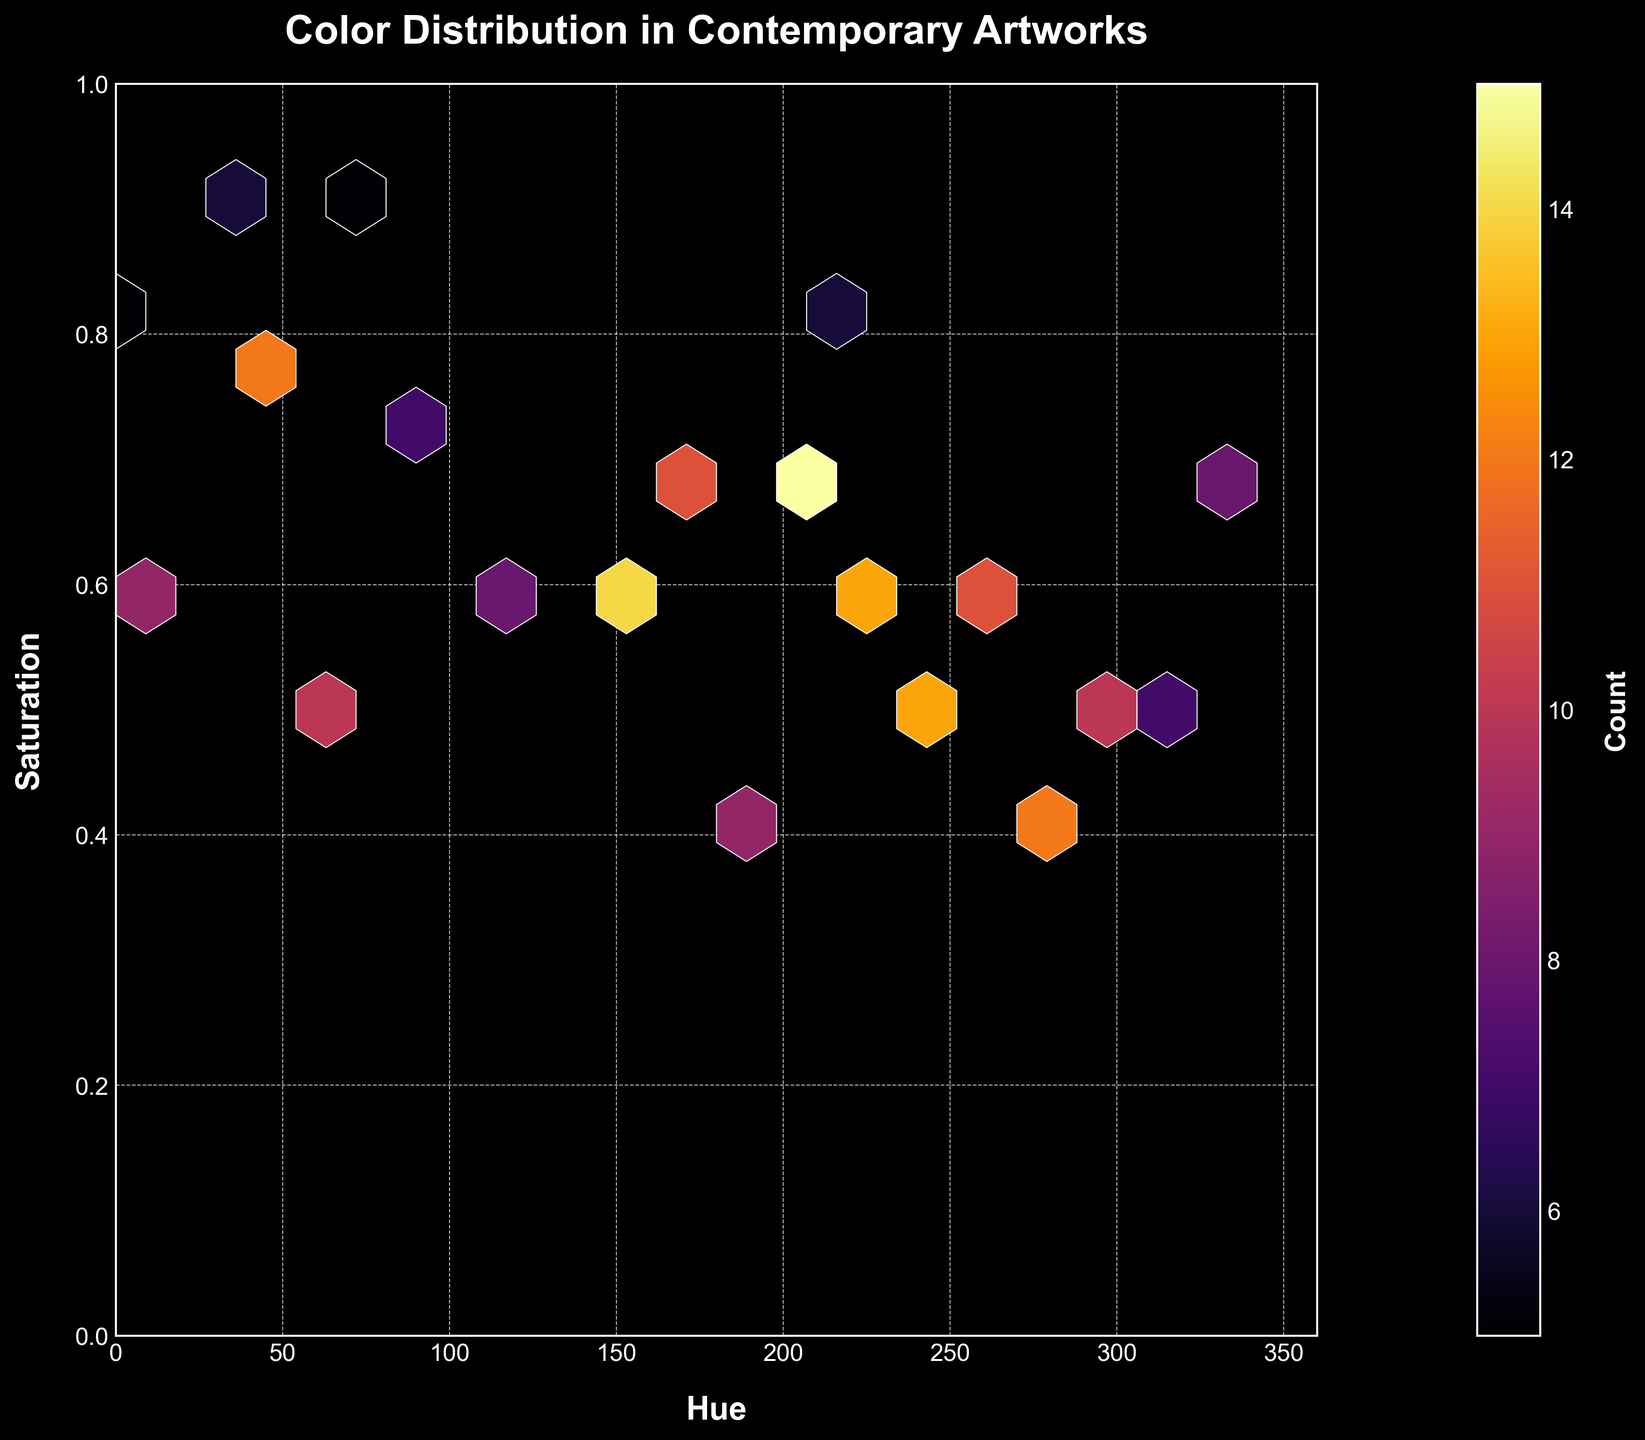What is the title of the figure? The title can be found at the top of the figure, where it is usually prominently displayed.
Answer: Color Distribution in Contemporary Artworks What are the labels on the x and y axes? The x-axis and y-axis labels are typically found near the axes themselves. Here, the x-axis label is "Hue" and the y-axis label is "Saturation."
Answer: Hue, Saturation What is the range of the Saturation axis? By looking at the y-axis, we can see that the range starts at 0 and goes up to 1.
Answer: 0 to 1 Which color region seems to have the highest density of points? The areas with the highest density typically appear brighter or more intense in a hexbin plot. In this plot, the region around (hue ~200, saturation ~0.7) appears to be the densest.
Answer: around (hue ~200, saturation ~0.7) What does the color of the hexagons represent? The color intensity in the hexagons represents the count of data points within that hexagon, as noted by the color bar labeled "Count."
Answer: Count of data points Compare the density at hue ~60, saturation ~0.5 and hue ~210, saturation ~0.8; which is higher? By observing the hexbin plot, the density is higher at hue ~60, saturation ~0.5. This is indicated by the brighter hexagon in that region compared to the one at hue ~210, saturation ~0.8.
Answer: hue ~60, saturation ~0.5 Which hue has the highest count at a saturation of 0.6? At saturation ~0.6, the brightest hexagon corresponds to the hue around 150.
Answer: hue ~150 What is the maximum count displayed in the color bar? The color bar indicates the maximum count by its upper limit. In this case, the maximum count displayed is 15.
Answer: 15 How does the density pattern change along the saturation axis as hue increases from 0 to 360? Observing the plot from left to right along the hue axis, density patterns vary with some dense areas around specific hues like 45, 120, and 200, but there is no consistent increase or decrease in density along the saturation axis.
Answer: Varies, no consistent pattern 